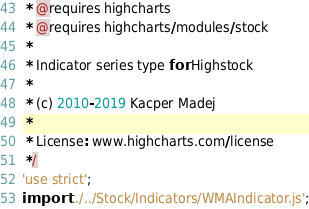<code> <loc_0><loc_0><loc_500><loc_500><_JavaScript_> * @requires highcharts
 * @requires highcharts/modules/stock
 *
 * Indicator series type for Highstock
 *
 * (c) 2010-2019 Kacper Madej
 *
 * License: www.highcharts.com/license
 */
'use strict';
import '../../Stock/Indicators/WMAIndicator.js';
</code> 